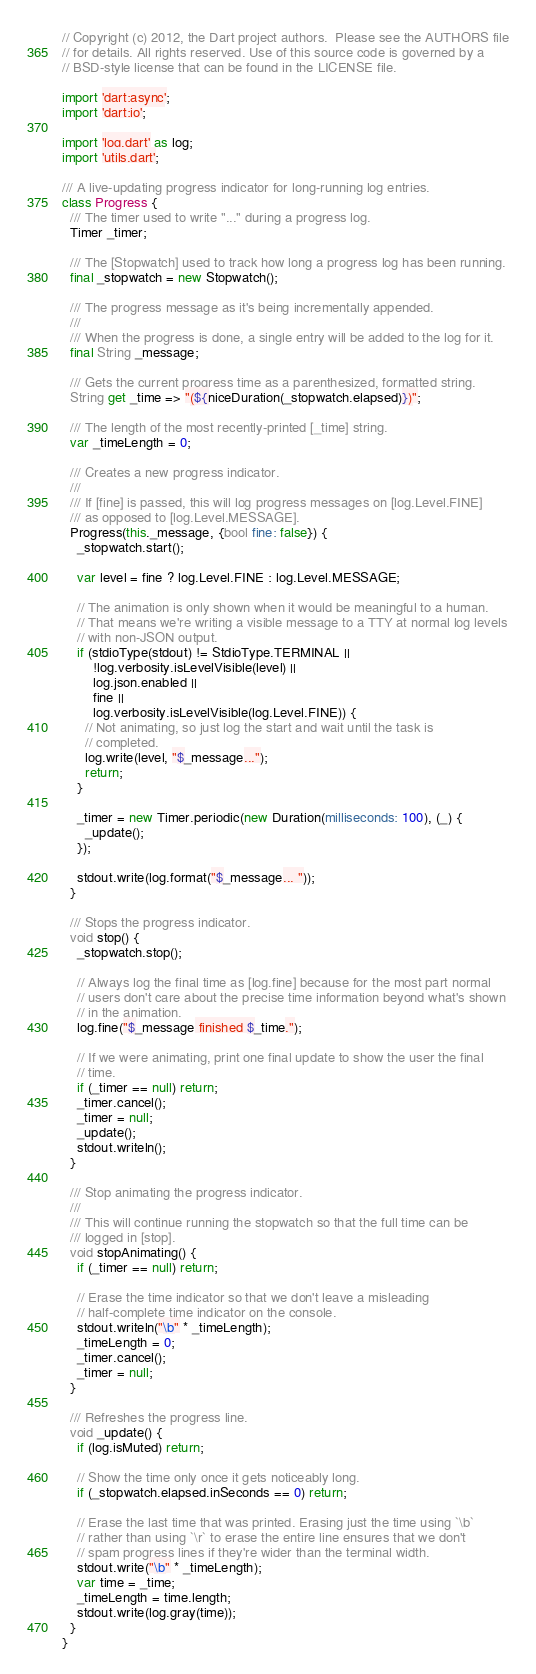<code> <loc_0><loc_0><loc_500><loc_500><_Dart_>// Copyright (c) 2012, the Dart project authors.  Please see the AUTHORS file
// for details. All rights reserved. Use of this source code is governed by a
// BSD-style license that can be found in the LICENSE file.

import 'dart:async';
import 'dart:io';

import 'log.dart' as log;
import 'utils.dart';

/// A live-updating progress indicator for long-running log entries.
class Progress {
  /// The timer used to write "..." during a progress log.
  Timer _timer;

  /// The [Stopwatch] used to track how long a progress log has been running.
  final _stopwatch = new Stopwatch();

  /// The progress message as it's being incrementally appended.
  ///
  /// When the progress is done, a single entry will be added to the log for it.
  final String _message;

  /// Gets the current progress time as a parenthesized, formatted string.
  String get _time => "(${niceDuration(_stopwatch.elapsed)})";

  /// The length of the most recently-printed [_time] string.
  var _timeLength = 0;

  /// Creates a new progress indicator.
  ///
  /// If [fine] is passed, this will log progress messages on [log.Level.FINE]
  /// as opposed to [log.Level.MESSAGE].
  Progress(this._message, {bool fine: false}) {
    _stopwatch.start();

    var level = fine ? log.Level.FINE : log.Level.MESSAGE;

    // The animation is only shown when it would be meaningful to a human.
    // That means we're writing a visible message to a TTY at normal log levels
    // with non-JSON output.
    if (stdioType(stdout) != StdioType.TERMINAL ||
        !log.verbosity.isLevelVisible(level) ||
        log.json.enabled ||
        fine ||
        log.verbosity.isLevelVisible(log.Level.FINE)) {
      // Not animating, so just log the start and wait until the task is
      // completed.
      log.write(level, "$_message...");
      return;
    }

    _timer = new Timer.periodic(new Duration(milliseconds: 100), (_) {
      _update();
    });

    stdout.write(log.format("$_message... "));
  }

  /// Stops the progress indicator.
  void stop() {
    _stopwatch.stop();

    // Always log the final time as [log.fine] because for the most part normal
    // users don't care about the precise time information beyond what's shown
    // in the animation.
    log.fine("$_message finished $_time.");

    // If we were animating, print one final update to show the user the final
    // time.
    if (_timer == null) return;
    _timer.cancel();
    _timer = null;
    _update();
    stdout.writeln();
  }

  /// Stop animating the progress indicator.
  ///
  /// This will continue running the stopwatch so that the full time can be
  /// logged in [stop].
  void stopAnimating() {
    if (_timer == null) return;

    // Erase the time indicator so that we don't leave a misleading
    // half-complete time indicator on the console.
    stdout.writeln("\b" * _timeLength);
    _timeLength = 0;
    _timer.cancel();
    _timer = null;
  }

  /// Refreshes the progress line.
  void _update() {
    if (log.isMuted) return;

    // Show the time only once it gets noticeably long.
    if (_stopwatch.elapsed.inSeconds == 0) return;

    // Erase the last time that was printed. Erasing just the time using `\b`
    // rather than using `\r` to erase the entire line ensures that we don't
    // spam progress lines if they're wider than the terminal width.
    stdout.write("\b" * _timeLength);
    var time = _time;
    _timeLength = time.length;
    stdout.write(log.gray(time));
  }
}
</code> 